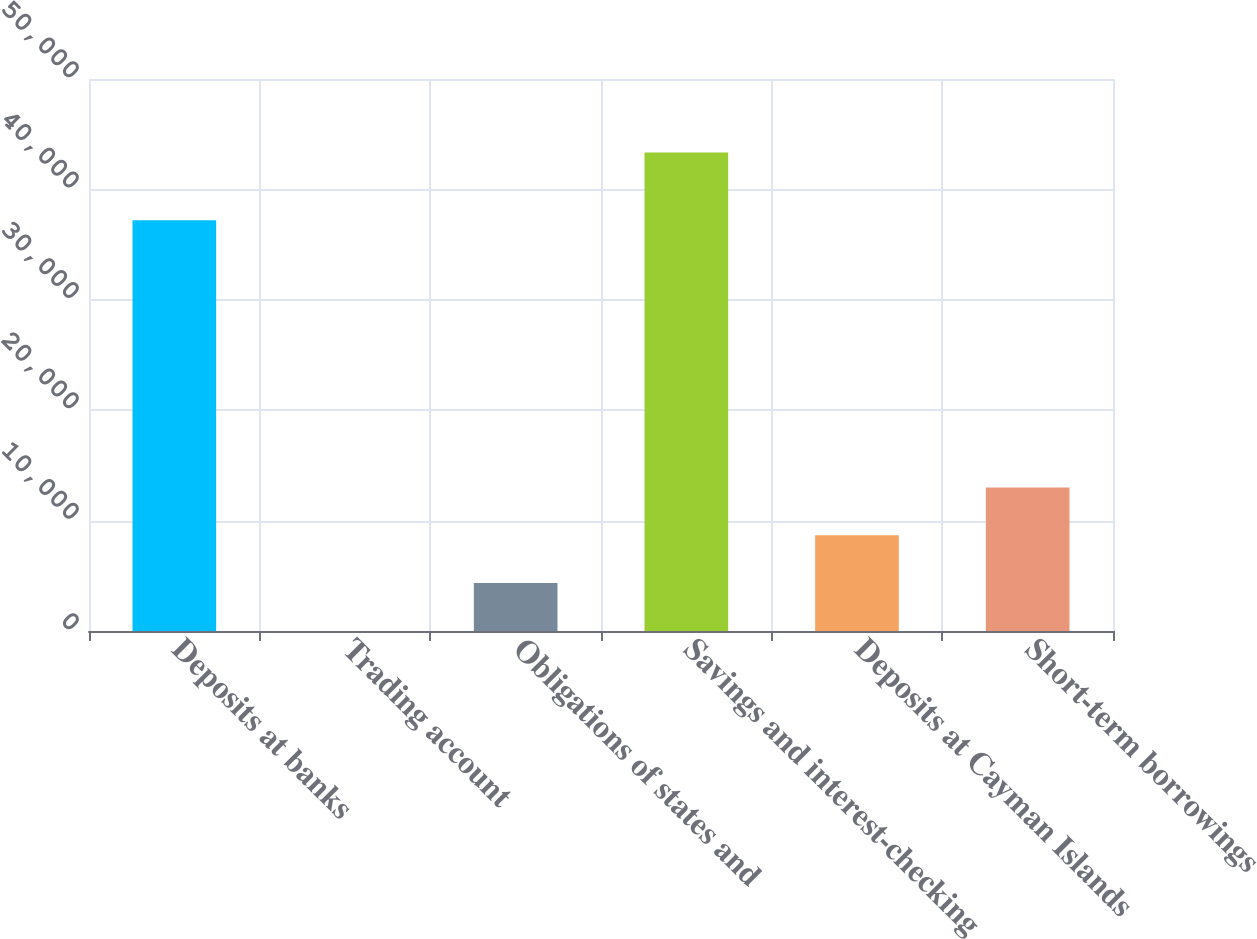Convert chart. <chart><loc_0><loc_0><loc_500><loc_500><bar_chart><fcel>Deposits at banks<fcel>Trading account<fcel>Obligations of states and<fcel>Savings and interest-checking<fcel>Deposits at Cayman Islands<fcel>Short-term borrowings<nl><fcel>37208<fcel>8<fcel>4341.3<fcel>43341<fcel>8674.6<fcel>13007.9<nl></chart> 